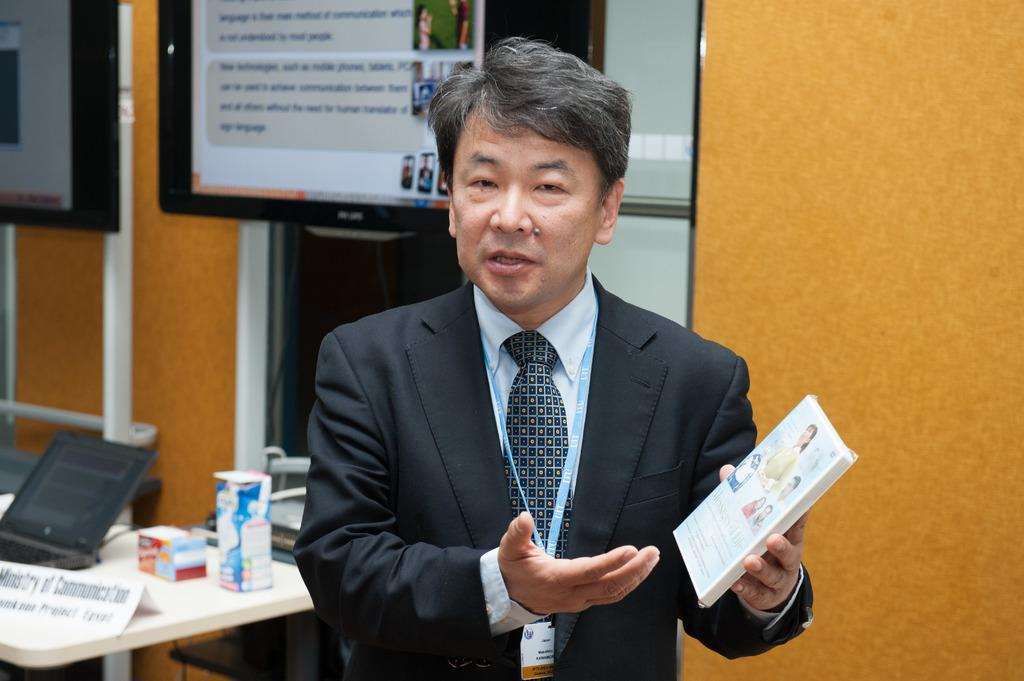What is the person in the image holding? The person is holding a box in the image. What can be seen to the left of the person? There is a table to the left of the person. What is on the table? There is a laptop, paper, and other objects on the table. What is visible in the background of the image? There is a screen visible in the background of the image. What shape is the time displayed on the person's wrist in the image? There is no time or wristwatch visible in the image, so it is not possible to determine the shape of any time display. 